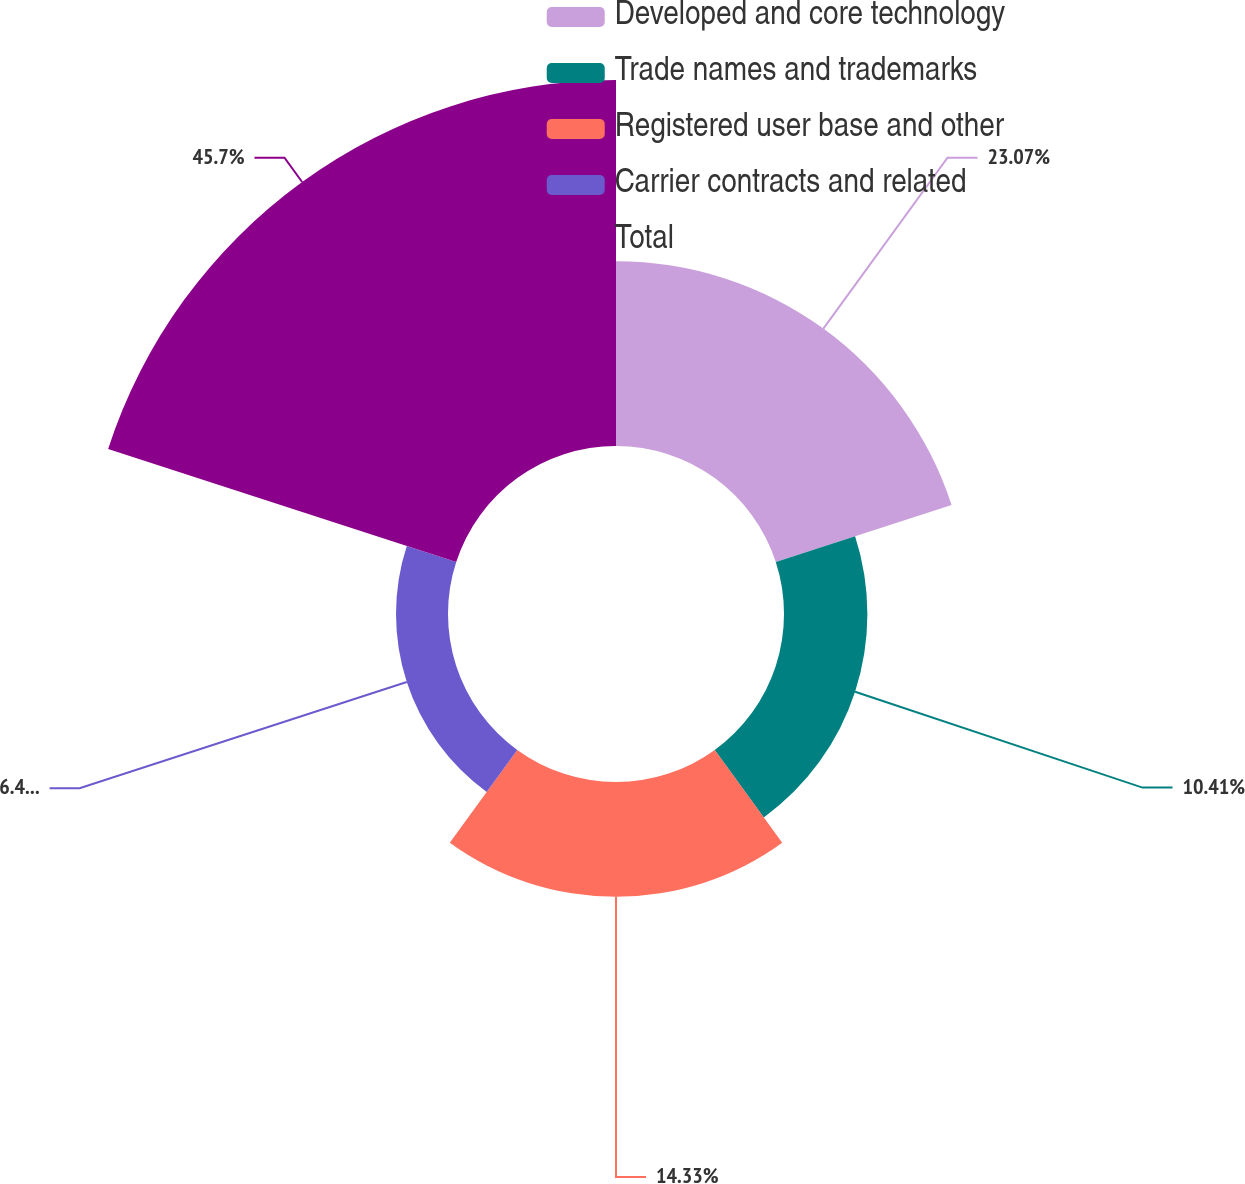Convert chart to OTSL. <chart><loc_0><loc_0><loc_500><loc_500><pie_chart><fcel>Developed and core technology<fcel>Trade names and trademarks<fcel>Registered user base and other<fcel>Carrier contracts and related<fcel>Total<nl><fcel>23.07%<fcel>10.41%<fcel>14.33%<fcel>6.49%<fcel>45.69%<nl></chart> 